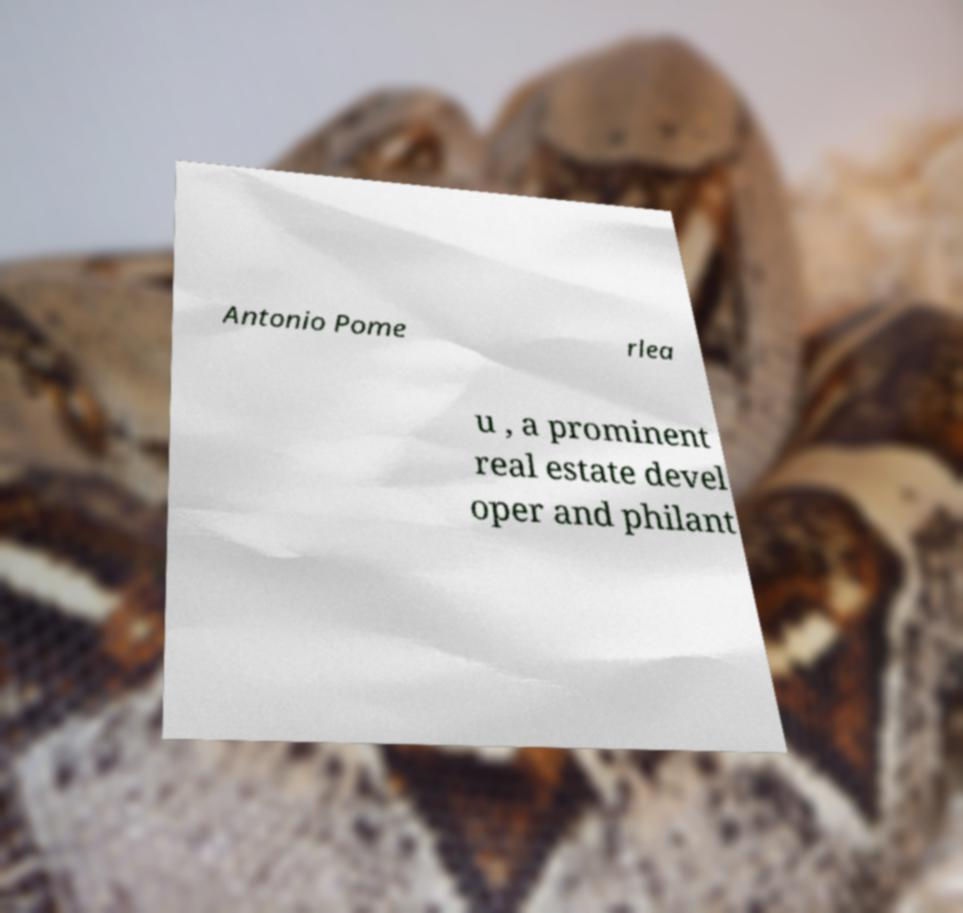Can you read and provide the text displayed in the image?This photo seems to have some interesting text. Can you extract and type it out for me? Antonio Pome rlea u , a prominent real estate devel oper and philant 